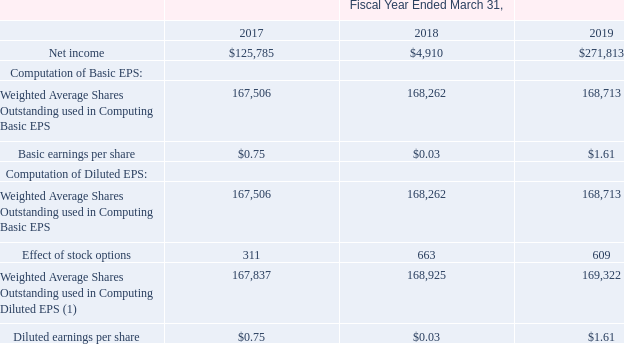2. Earnings Per Share:
Basic earnings per share are computed by dividing net earnings by the weighted average number of shares of common stock outstanding for the period. Diluted
earnings per share are computed by dividing net earnings by the sum of (a) the weighted average number of shares of common stock outstanding during the period and
(b) the dilutive effect of potential common stock equivalents during the period. Stock options and unvested service-based RSU awards make up the common stock
equivalents and are computed using the treasury stock method.
The table below represents the basic and diluted earnings per share, calculated using the weighted average number of shares of common stock and potential
common stock equivalents outstanding for the years ended March 31, 2017, 2018, and 2019:
(1) Common stock equivalents not included in the computation of diluted earnings per share because the impact would have been anti-dilutive were 1,381 shares, 1,733
shares, and 4,375 shares for the fiscal years ended March 31, 2017, 2018, and 2019, respectively.
What is the net income in the fiscal year ended March 31, 2017? $125,785. What is the net income in the fiscal year ended March 31, 2018? $4,910. What is the net income in the fiscal year ended March 31, 2019? $271,813. What is the total number of weighted average shares outstanding used in computing diluted EPS in 2017 and 2018? 167,837 + 168,925 
Answer: 336762. What is the percentage of common stock equivalents not included in the computation of diluted earnings as a percentage of the weighted average shares outstanding used in computing diluted EPS in 2019?
Answer scale should be: percent. 4,375/169,322 
Answer: 2.58. What is the sum of the weighted average shares outstanding used in computing diluted EPS and the common stock equivalents not included in 2018? 168,925 + 1,733 
Answer: 170658. 